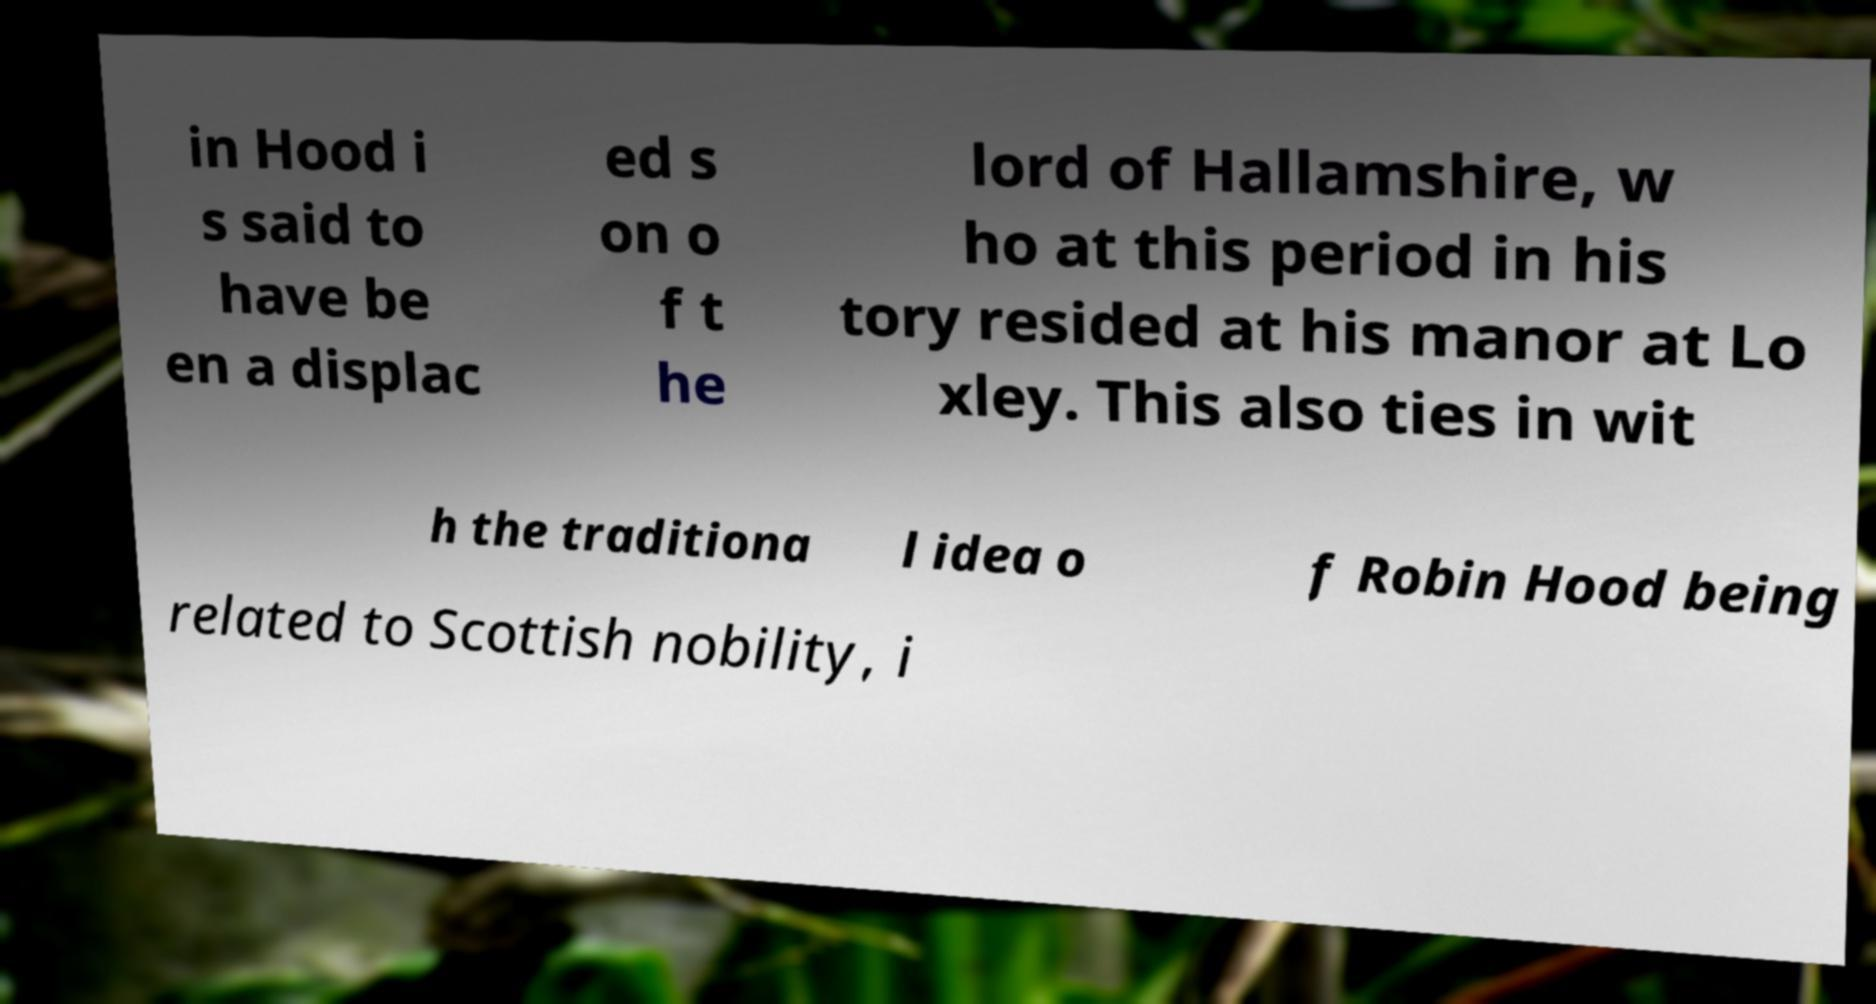Please identify and transcribe the text found in this image. in Hood i s said to have be en a displac ed s on o f t he lord of Hallamshire, w ho at this period in his tory resided at his manor at Lo xley. This also ties in wit h the traditiona l idea o f Robin Hood being related to Scottish nobility, i 